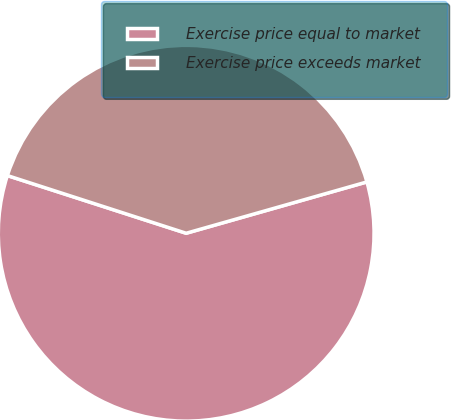Convert chart. <chart><loc_0><loc_0><loc_500><loc_500><pie_chart><fcel>Exercise price equal to market<fcel>Exercise price exceeds market<nl><fcel>59.37%<fcel>40.63%<nl></chart> 